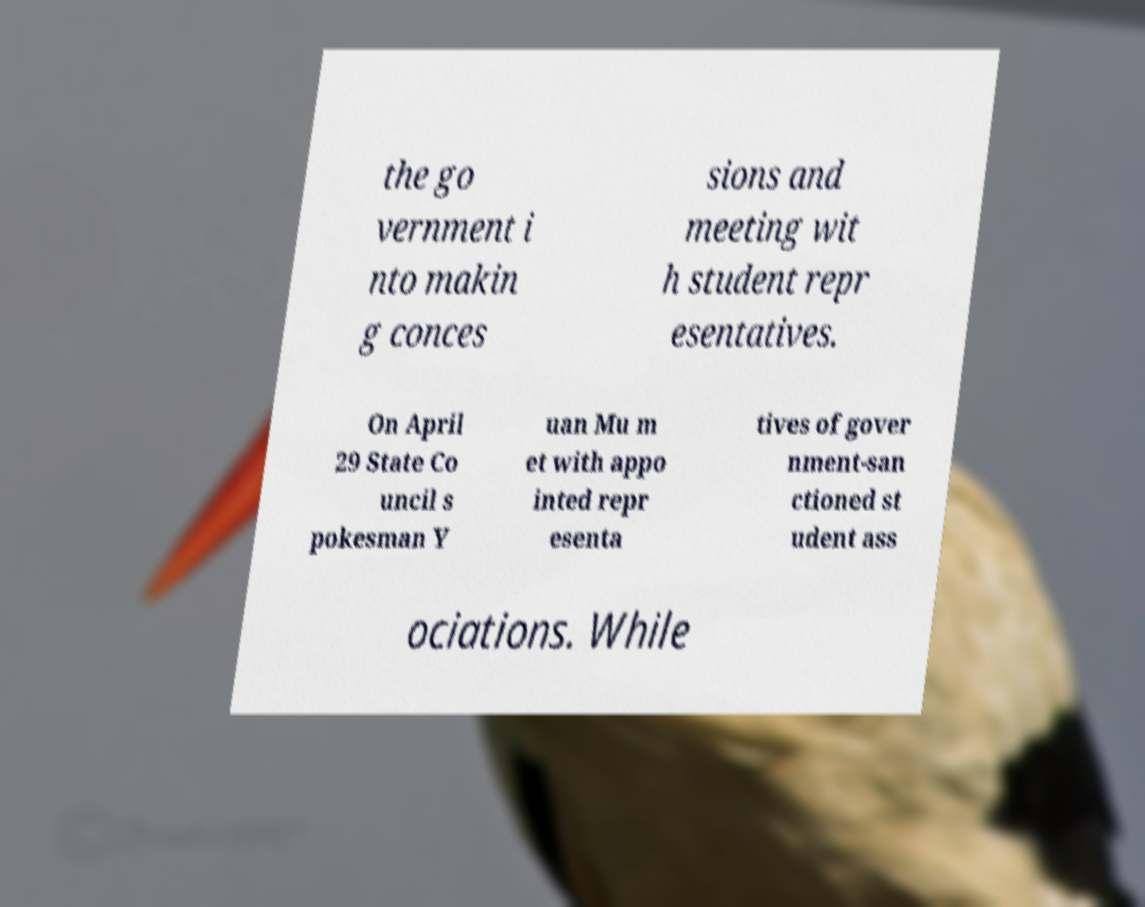Could you assist in decoding the text presented in this image and type it out clearly? the go vernment i nto makin g conces sions and meeting wit h student repr esentatives. On April 29 State Co uncil s pokesman Y uan Mu m et with appo inted repr esenta tives of gover nment-san ctioned st udent ass ociations. While 